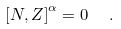Convert formula to latex. <formula><loc_0><loc_0><loc_500><loc_500>\left [ N , Z \right ] ^ { \alpha } = 0 \ \ .</formula> 